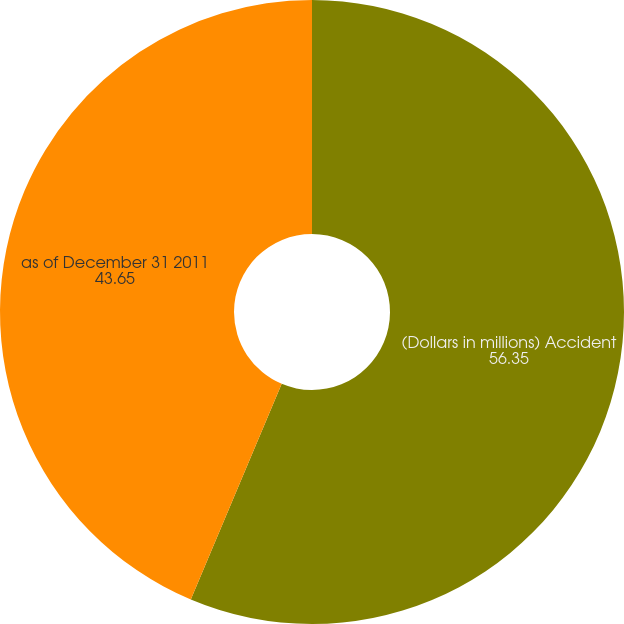Convert chart. <chart><loc_0><loc_0><loc_500><loc_500><pie_chart><fcel>(Dollars in millions) Accident<fcel>as of December 31 2011<nl><fcel>56.35%<fcel>43.65%<nl></chart> 